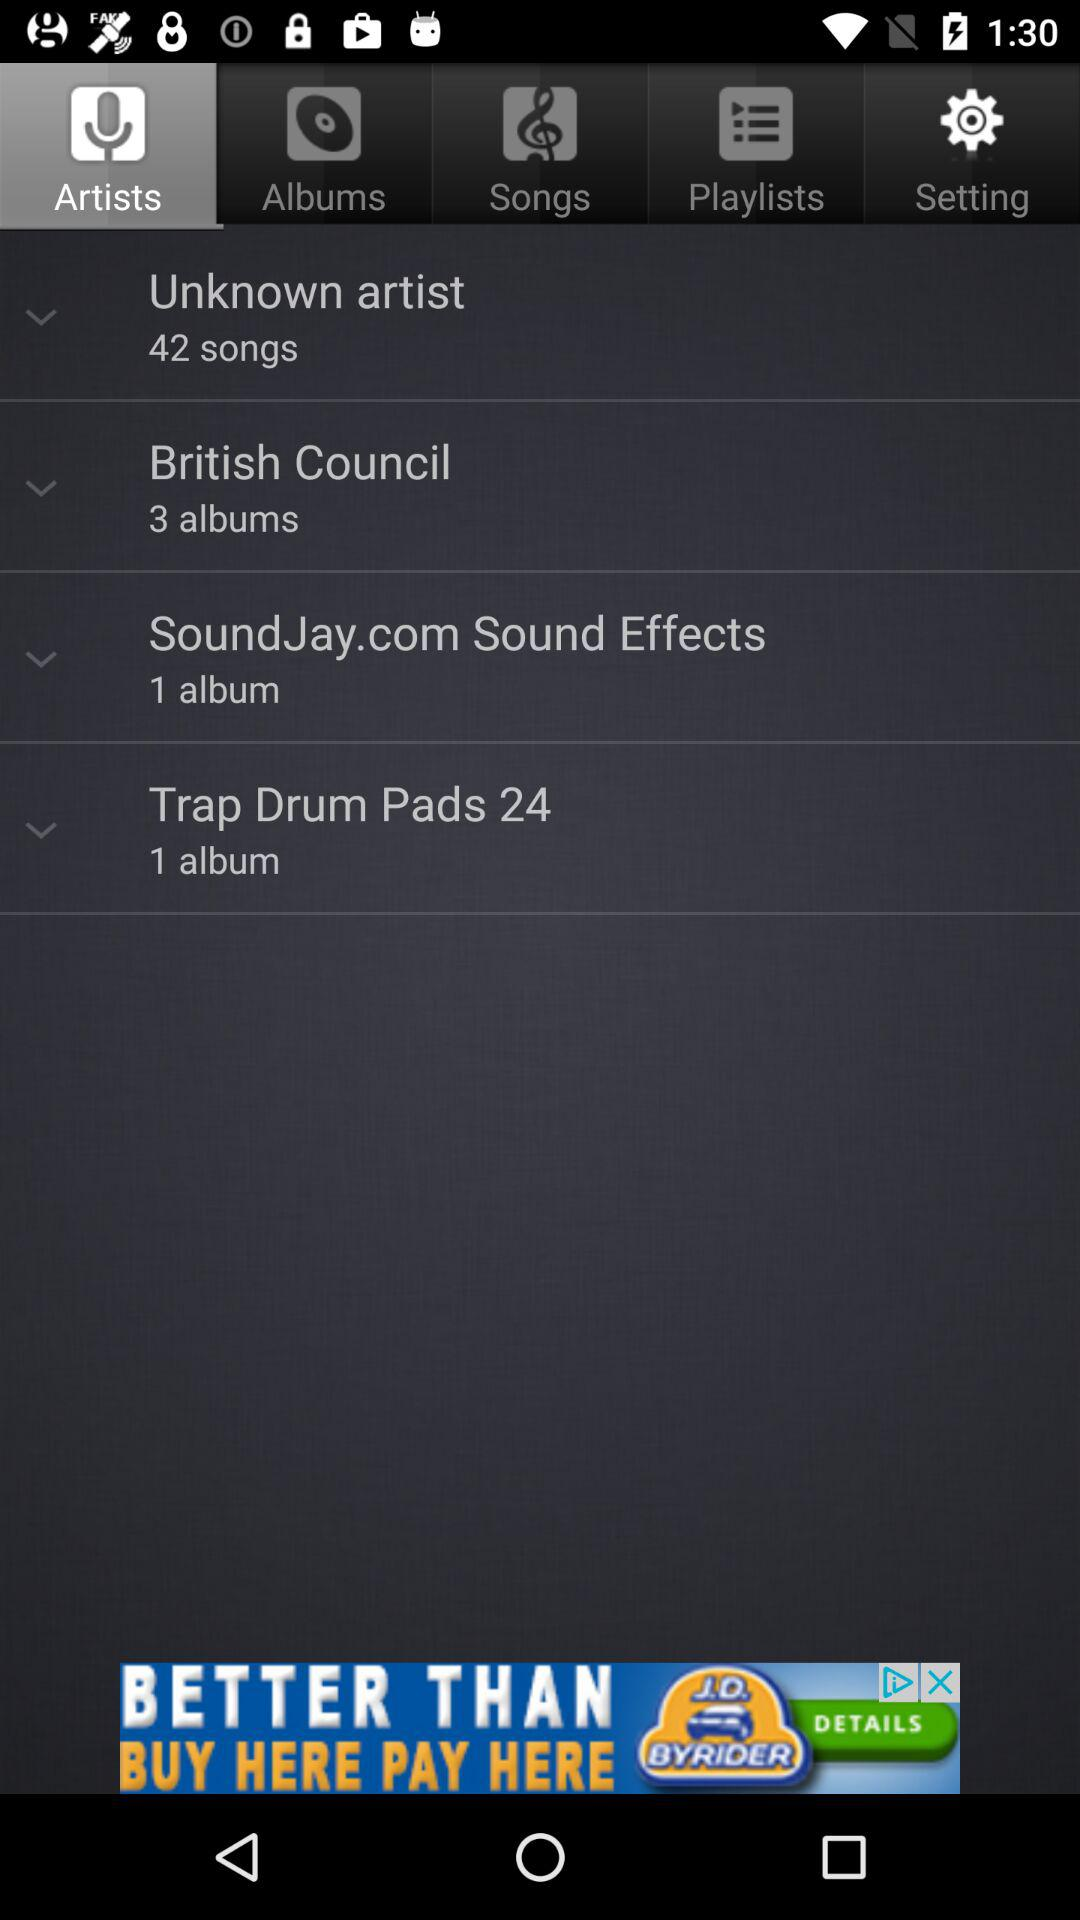How many more albums does the British Council artist have than the Trap Drum Pads artist?
Answer the question using a single word or phrase. 2 